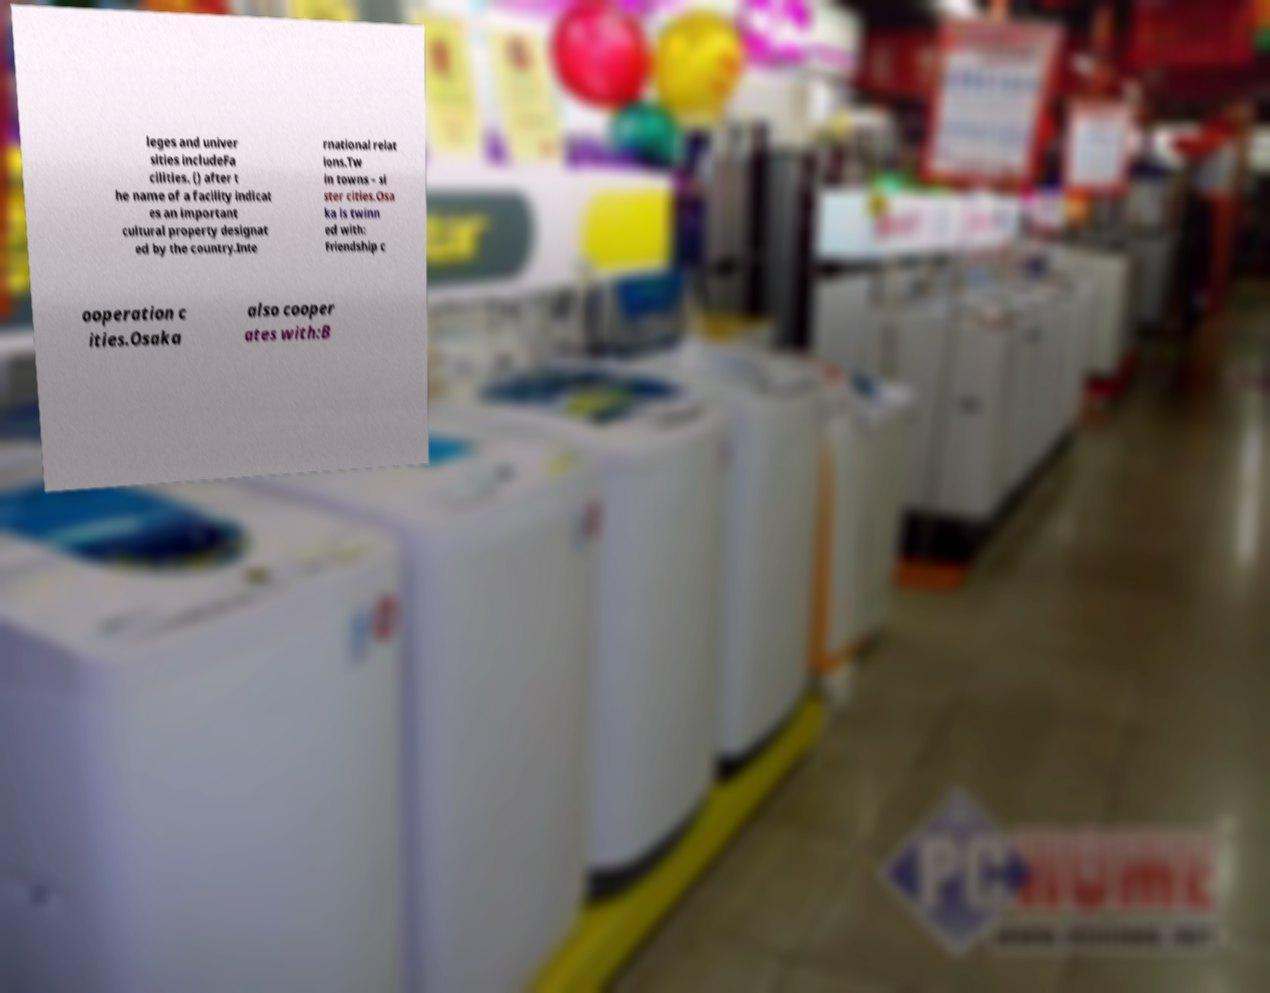I need the written content from this picture converted into text. Can you do that? leges and univer sities includeFa cilities. () after t he name of a facility indicat es an important cultural property designat ed by the country.Inte rnational relat ions.Tw in towns – si ster cities.Osa ka is twinn ed with: Friendship c ooperation c ities.Osaka also cooper ates with:B 